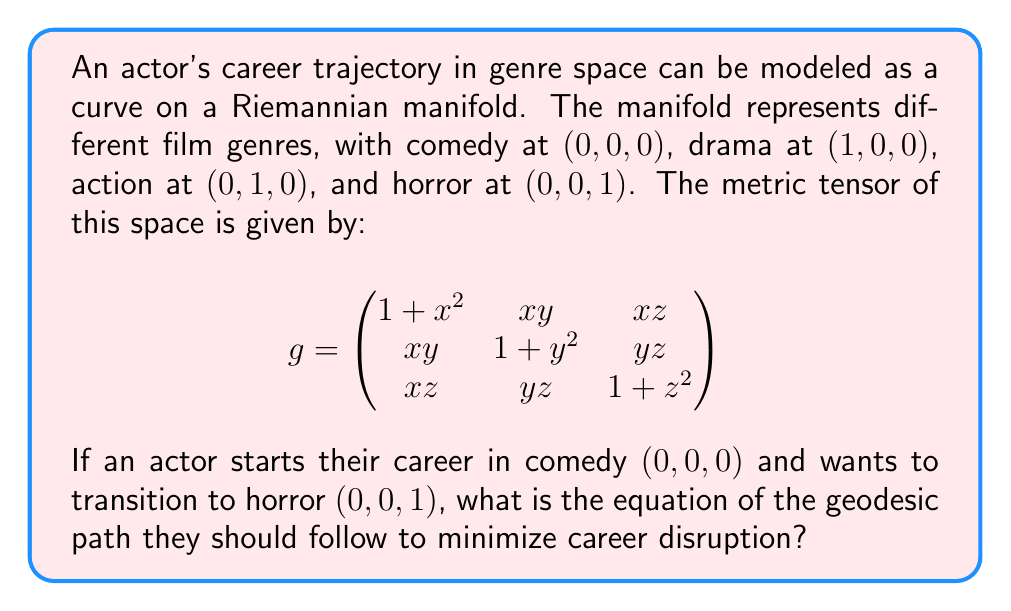Can you answer this question? To find the geodesic path, we need to solve the geodesic equation:

$$\frac{d^2x^i}{dt^2} + \Gamma^i_{jk}\frac{dx^j}{dt}\frac{dx^k}{dt} = 0$$

Where $\Gamma^i_{jk}$ are the Christoffel symbols of the second kind.

Step 1: Calculate the Christoffel symbols using the metric tensor.

$$\Gamma^i_{jk} = \frac{1}{2}g^{im}(\frac{\partial g_{mj}}{\partial x^k} + \frac{\partial g_{mk}}{\partial x^j} - \frac{\partial g_{jk}}{\partial x^m})$$

Step 2: Due to the symmetry of the metric tensor, we can deduce that the geodesic will be a straight line in the z-direction:

$$x(t) = 0, y(t) = 0, z(t) = t$$

Step 3: Verify this solution satisfies the geodesic equation for each component:

For x and y components:
$$\frac{d^2x}{dt^2} = \frac{d^2y}{dt^2} = 0$$

For z component:
$$\frac{d^2z}{dt^2} = 0$$

All Christoffel symbols with i = 3 (z-component) and j,k = 3 are zero when x = y = 0.

Step 4: The geodesic path equation is therefore:

$$\gamma(t) = (0, 0, t), \quad 0 \leq t \leq 1$$

This represents a straight line from (0,0,0) to (0,0,1) in the genre space.
Answer: $\gamma(t) = (0, 0, t), \quad 0 \leq t \leq 1$ 